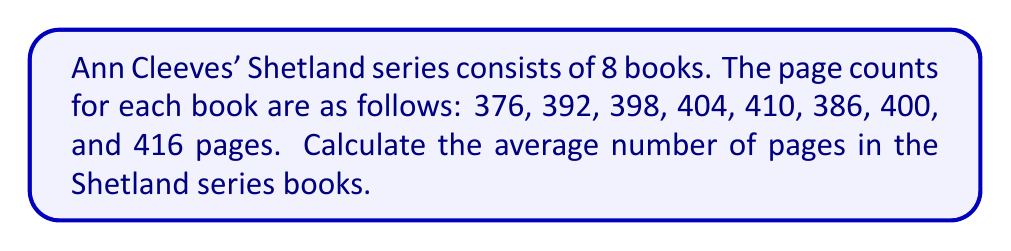Give your solution to this math problem. To find the average number of pages, we need to:
1. Sum up the total number of pages for all books
2. Divide the total by the number of books

Step 1: Calculate the total number of pages
$$\text{Total pages} = 376 + 392 + 398 + 404 + 410 + 386 + 400 + 416 = 3182$$

Step 2: Divide the total by the number of books (8)
$$\text{Average} = \frac{\text{Total pages}}{\text{Number of books}} = \frac{3182}{8} = 397.75$$

Therefore, the average number of pages in Ann Cleeves' Shetland series books is 397.75 pages.
Answer: 397.75 pages 